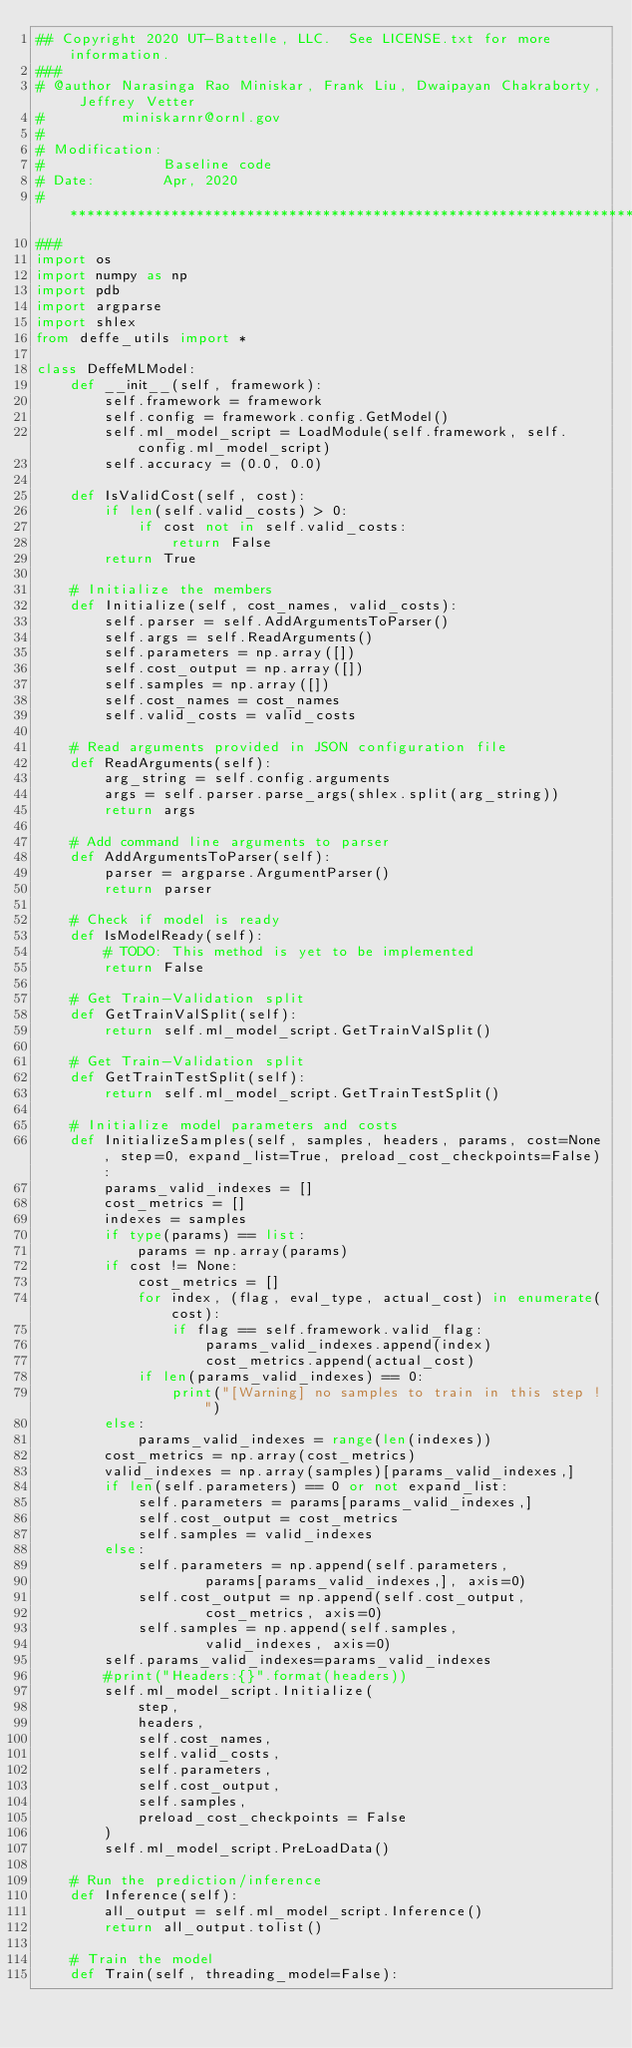<code> <loc_0><loc_0><loc_500><loc_500><_Python_>## Copyright 2020 UT-Battelle, LLC.  See LICENSE.txt for more information.
###
# @author Narasinga Rao Miniskar, Frank Liu, Dwaipayan Chakraborty, Jeffrey Vetter
#         miniskarnr@ornl.gov
#
# Modification:
#              Baseline code
# Date:        Apr, 2020
# **************************************************************************
###
import os
import numpy as np
import pdb
import argparse
import shlex
from deffe_utils import *

class DeffeMLModel:
    def __init__(self, framework):
        self.framework = framework
        self.config = framework.config.GetModel()
        self.ml_model_script = LoadModule(self.framework, self.config.ml_model_script)
        self.accuracy = (0.0, 0.0)

    def IsValidCost(self, cost):
        if len(self.valid_costs) > 0:
            if cost not in self.valid_costs:
                return False
        return True

    # Initialize the members
    def Initialize(self, cost_names, valid_costs):
        self.parser = self.AddArgumentsToParser()
        self.args = self.ReadArguments()
        self.parameters = np.array([])
        self.cost_output = np.array([])
        self.samples = np.array([])
        self.cost_names = cost_names
        self.valid_costs = valid_costs

    # Read arguments provided in JSON configuration file
    def ReadArguments(self):
        arg_string = self.config.arguments
        args = self.parser.parse_args(shlex.split(arg_string))
        return args

    # Add command line arguments to parser
    def AddArgumentsToParser(self):
        parser = argparse.ArgumentParser()
        return parser

    # Check if model is ready
    def IsModelReady(self):
        # TODO: This method is yet to be implemented
        return False

    # Get Train-Validation split
    def GetTrainValSplit(self):
        return self.ml_model_script.GetTrainValSplit()

    # Get Train-Validation split
    def GetTrainTestSplit(self):
        return self.ml_model_script.GetTrainTestSplit()

    # Initialize model parameters and costs
    def InitializeSamples(self, samples, headers, params, cost=None, step=0, expand_list=True, preload_cost_checkpoints=False):
        params_valid_indexes = []
        cost_metrics = []
        indexes = samples
        if type(params) == list:
            params = np.array(params)
        if cost != None:
            cost_metrics = []
            for index, (flag, eval_type, actual_cost) in enumerate(cost):
                if flag == self.framework.valid_flag:
                    params_valid_indexes.append(index)
                    cost_metrics.append(actual_cost)
            if len(params_valid_indexes) == 0:
                print("[Warning] no samples to train in this step !")
        else:
            params_valid_indexes = range(len(indexes))
        cost_metrics = np.array(cost_metrics)
        valid_indexes = np.array(samples)[params_valid_indexes,]
        if len(self.parameters) == 0 or not expand_list:
            self.parameters = params[params_valid_indexes,]
            self.cost_output = cost_metrics
            self.samples = valid_indexes
        else:
            self.parameters = np.append(self.parameters, 
                    params[params_valid_indexes,], axis=0)
            self.cost_output = np.append(self.cost_output, 
                    cost_metrics, axis=0)
            self.samples = np.append(self.samples, 
                    valid_indexes, axis=0)
        self.params_valid_indexes=params_valid_indexes
        #print("Headers:{}".format(headers))
        self.ml_model_script.Initialize(
            step,
            headers,
            self.cost_names,
            self.valid_costs,
            self.parameters,
            self.cost_output,
            self.samples,
            preload_cost_checkpoints = False
        )
        self.ml_model_script.PreLoadData()

    # Run the prediction/inference
    def Inference(self):
        all_output = self.ml_model_script.Inference()
        return all_output.tolist()

    # Train the model
    def Train(self, threading_model=False):</code> 